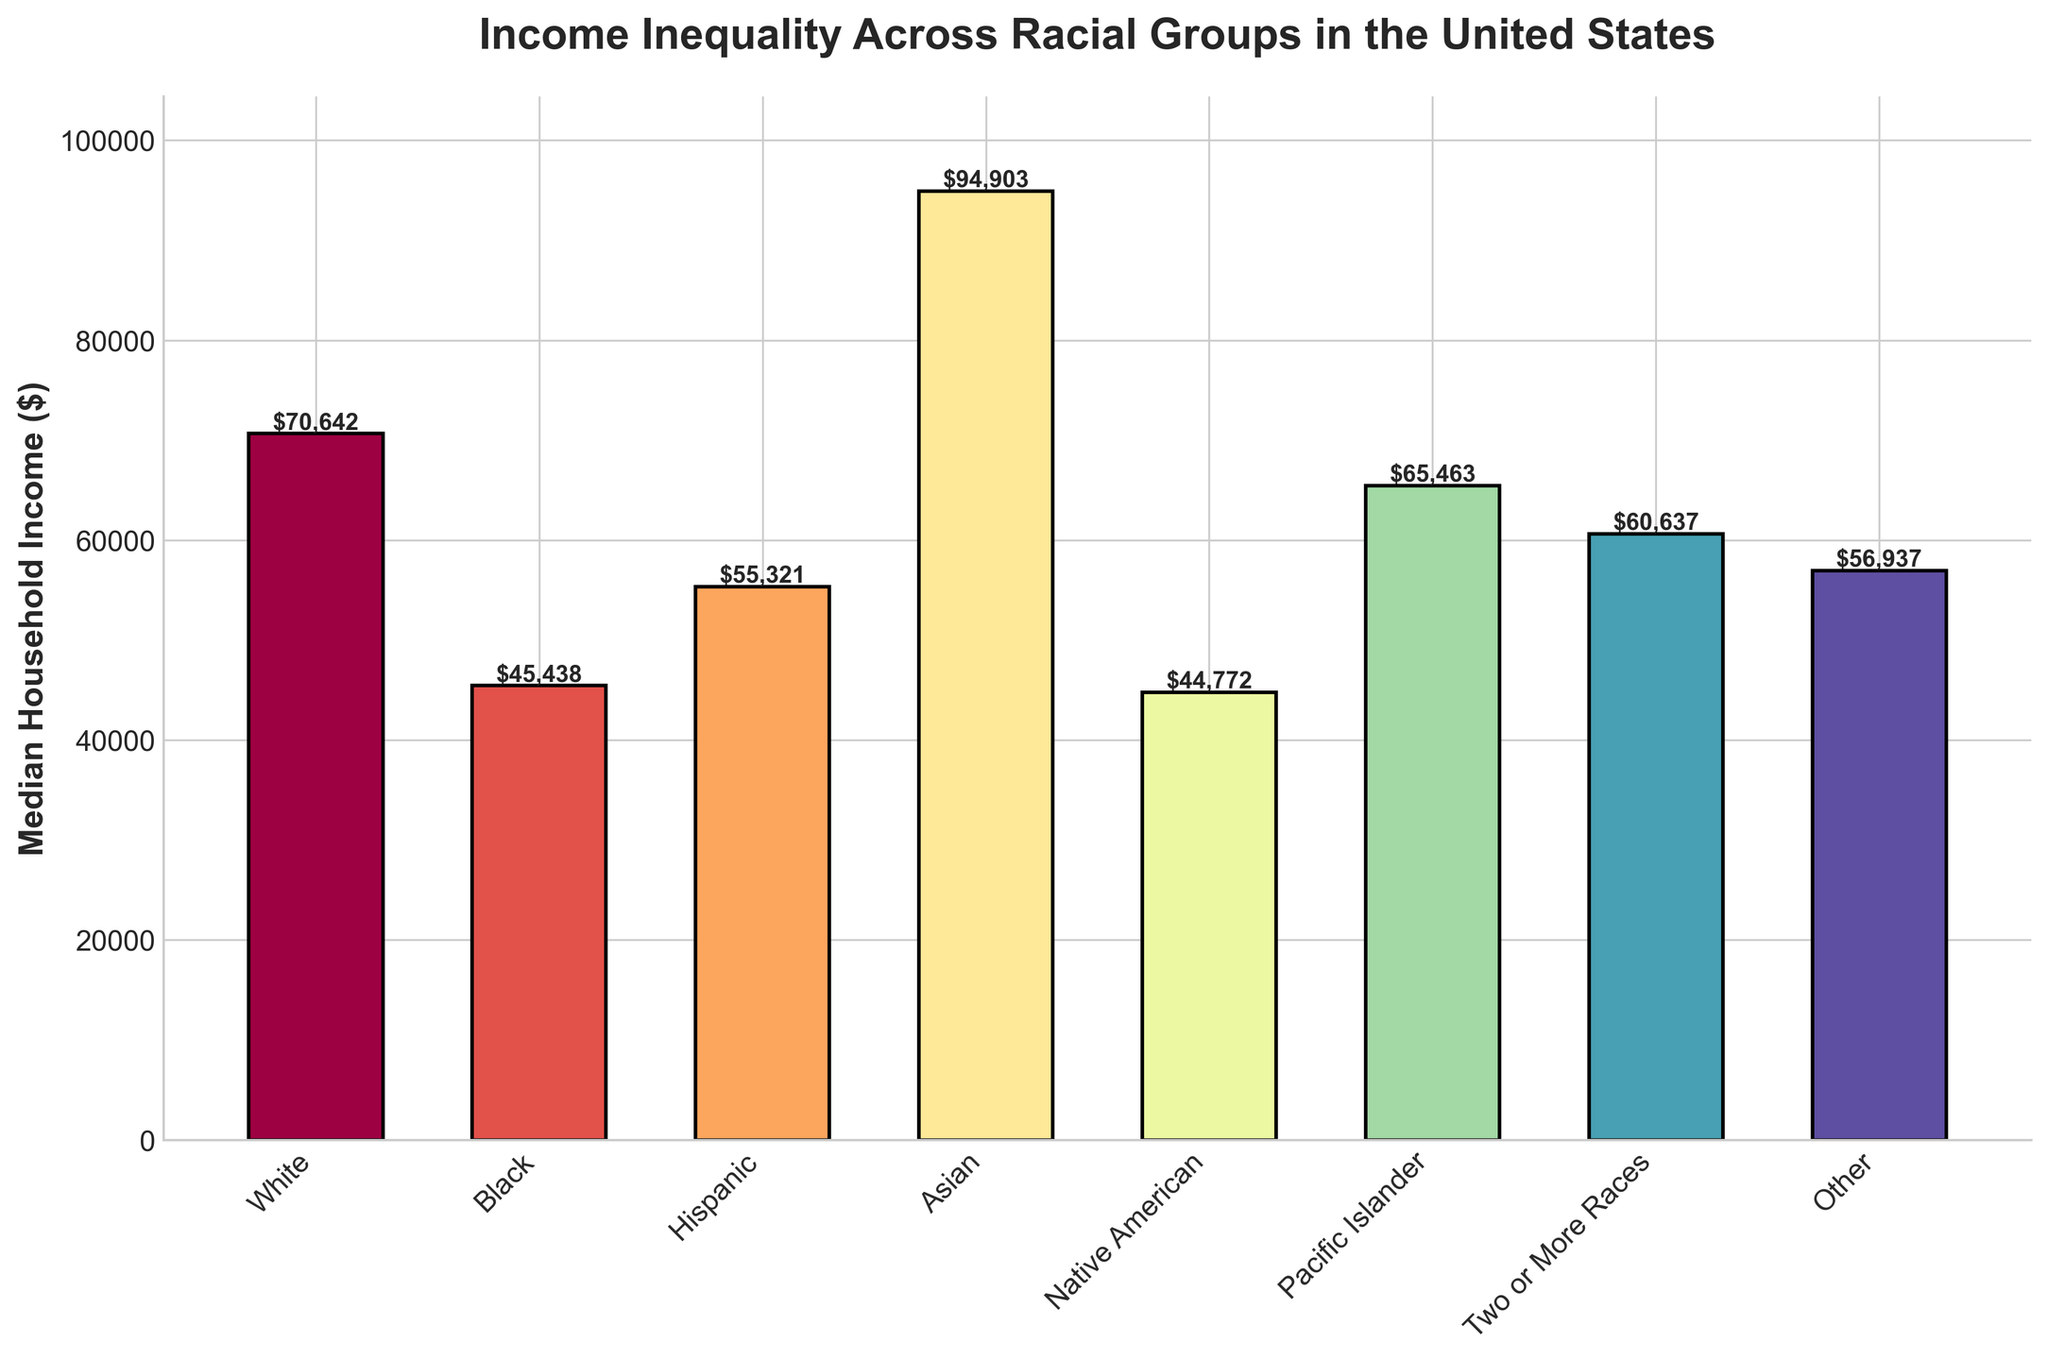What is the median household income difference between White and Black racial groups? Look at the median household incomes for White ($70,642) and Black ($45,438) populations on the chart. Subtract $45,438 from $70,642.
Answer: $25,204 Which racial group has the highest median household income? Identify the bar that reaches the highest point on the chart. The bar for Asians is the highest, corresponding to a median household income of $94,903.
Answer: Asian What is the total median household income of Hispanic and Pacific Islander racial groups combined? Add the median household incomes for Hispanic ($55,321) and Pacific Islander ($65,463). Sum them up: $55,321 + $65,463.
Answer: $120,784 How much greater is the median household income of Asian compared to Native American racial groups? Look at the values in the chart: Asian ($94,903) and Native American ($44,772). Subtract $44,772 from $94,903.
Answer: $50,131 Which racial group has a median household income closest to $60,000? Evaluate the bars in the chart to identify the closest value to $60,000. The bar for Two or More Races shows $60,637, which is closest to $60,000.
Answer: Two or More Races What is the average median household income across all racial groups presented? Sum the median incomes of all groups ($70,642 + $45,438 + $55,321 + $94,903 + $44,772 + $65,463 + $60,637 + $56,937) and divide by the number of groups (8). Calculation: (70,642 + 45,438 + 55,321 + 94,903 + 44,772 + 65,463 + 60,637 + 56,937) / 8 = 494,113 / 8.
Answer: $61,764 Which racial groups have median household incomes less than $50,000? Identify the bars that correspond to incomes less than $50,000. The groups with incomes below this level are Black ($45,438) and Native American ($44,772).
Answer: Black, Native American Is the median household income of the "Other" racial group closer to White or Hispanic groups? Compare the median household income of the "Other" group ($56,937) to those of the White ($70,642) and Hispanic ($55,321) groups by calculating the differences:
Answer: Hispanic How do the median household incomes of Pacific Islander and Two or More Races groups compare visually? Observe the heights of the bars representing Pacific Islander ($65,463) and Two or More Races ($60,637). The Pacific Islander bar is higher.
Answer: Pacific Islander has a higher income 